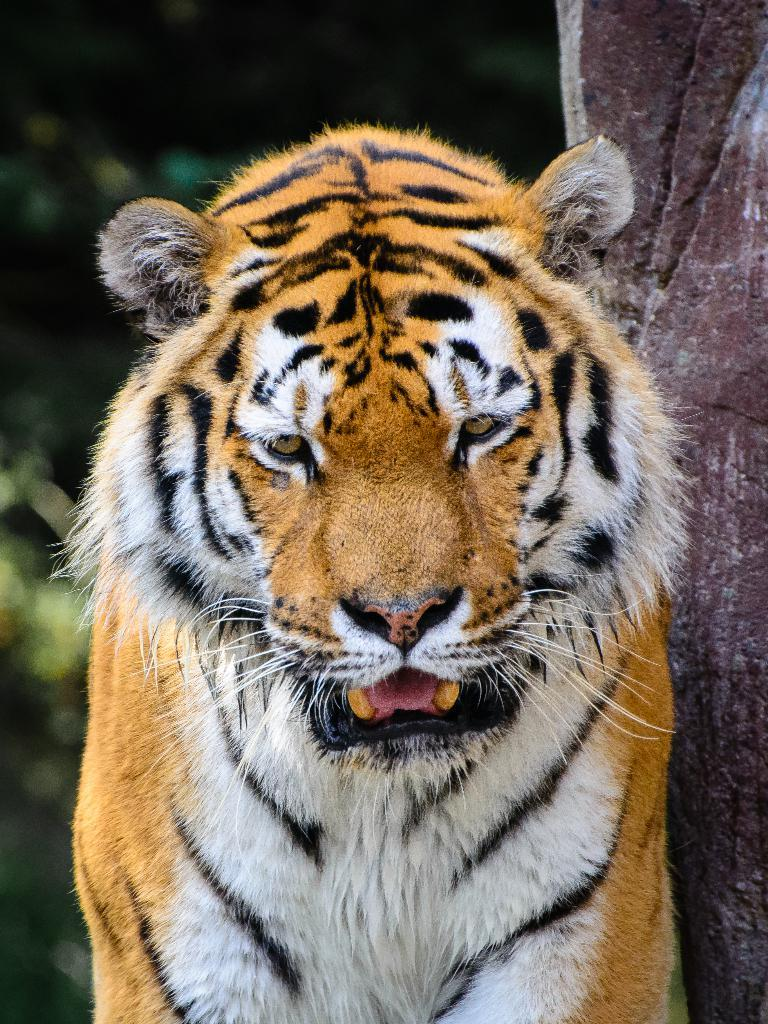What type of animal is in the image? There is a tiger in the image. Can you describe the object on the right side of the image? Unfortunately, the provided facts do not give any information about the object on the right side of the image. What type of sea creature is playing the guitar in the image? There is no sea creature or guitar present in the image; it features a tiger. What type of bag is visible on the left side of the image? The provided facts do not mention a bag or its location in the image. 